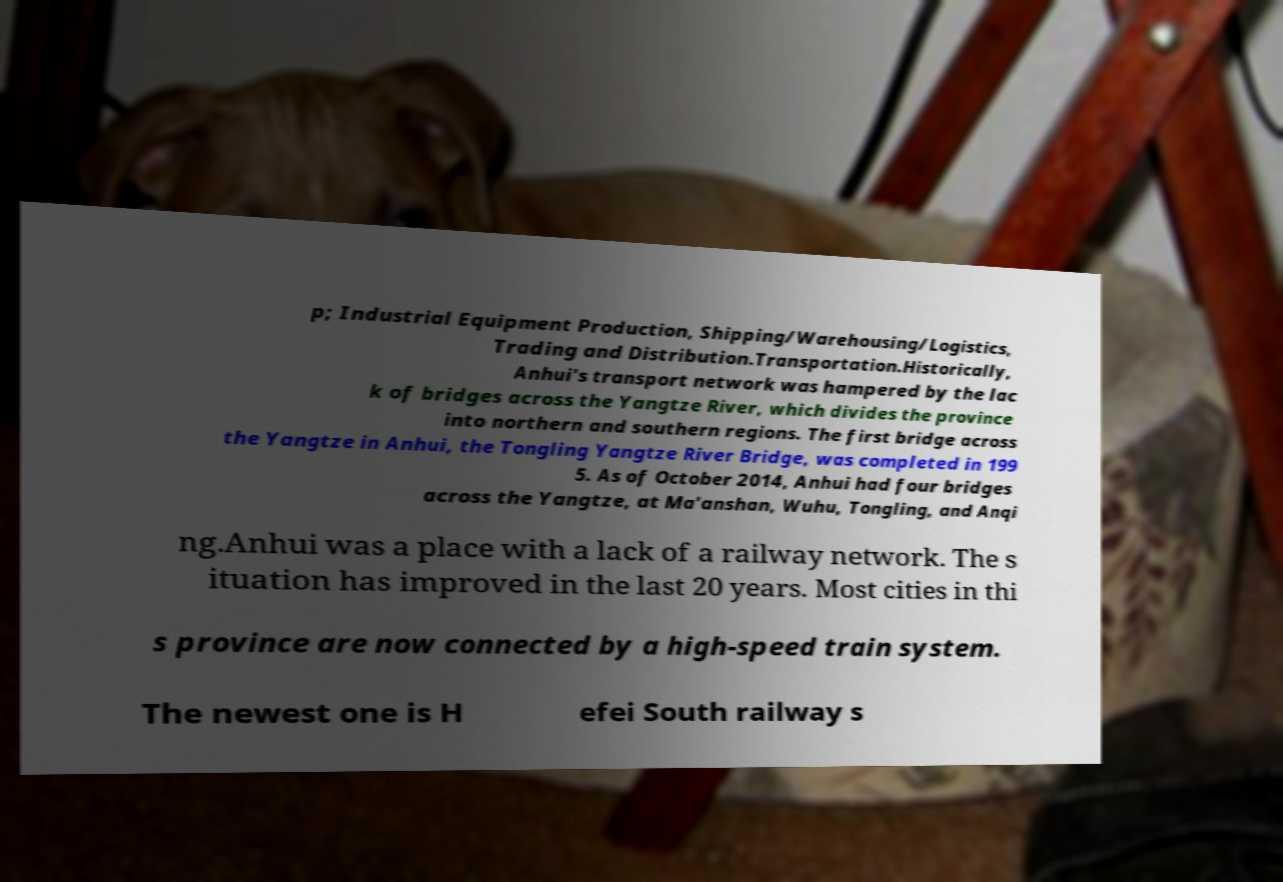Could you assist in decoding the text presented in this image and type it out clearly? p; Industrial Equipment Production, Shipping/Warehousing/Logistics, Trading and Distribution.Transportation.Historically, Anhui's transport network was hampered by the lac k of bridges across the Yangtze River, which divides the province into northern and southern regions. The first bridge across the Yangtze in Anhui, the Tongling Yangtze River Bridge, was completed in 199 5. As of October 2014, Anhui had four bridges across the Yangtze, at Ma'anshan, Wuhu, Tongling, and Anqi ng.Anhui was a place with a lack of a railway network. The s ituation has improved in the last 20 years. Most cities in thi s province are now connected by a high-speed train system. The newest one is H efei South railway s 